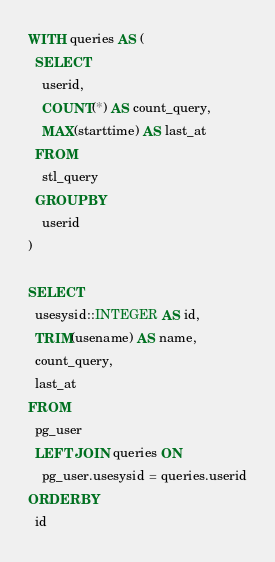Convert code to text. <code><loc_0><loc_0><loc_500><loc_500><_SQL_>WITH queries AS (
  SELECT
    userid,
    COUNT(*) AS count_query,
    MAX(starttime) AS last_at
  FROM
    stl_query
  GROUP BY
    userid
)

SELECT
  usesysid::INTEGER AS id,
  TRIM(usename) AS name,
  count_query,
  last_at
FROM
  pg_user
  LEFT JOIN queries ON
    pg_user.usesysid = queries.userid
ORDER BY
  id
</code> 